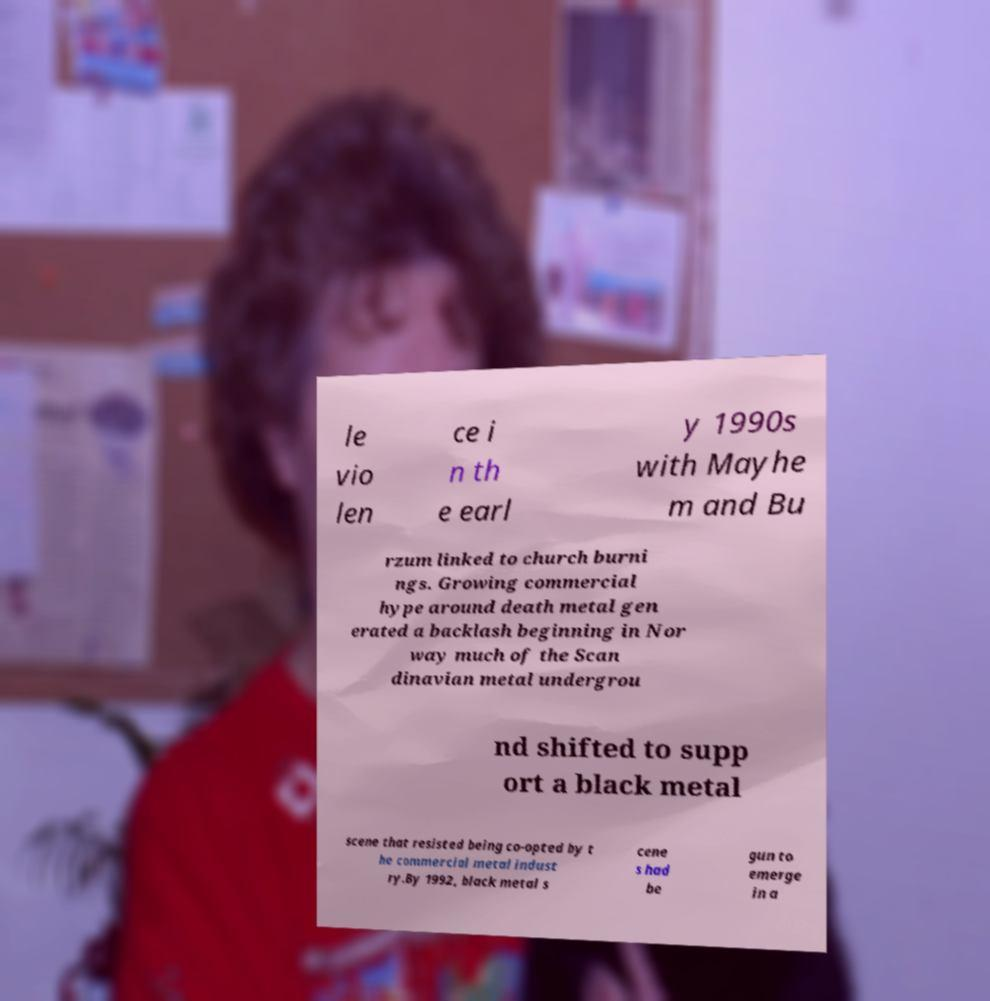Please read and relay the text visible in this image. What does it say? le vio len ce i n th e earl y 1990s with Mayhe m and Bu rzum linked to church burni ngs. Growing commercial hype around death metal gen erated a backlash beginning in Nor way much of the Scan dinavian metal undergrou nd shifted to supp ort a black metal scene that resisted being co-opted by t he commercial metal indust ry.By 1992, black metal s cene s had be gun to emerge in a 